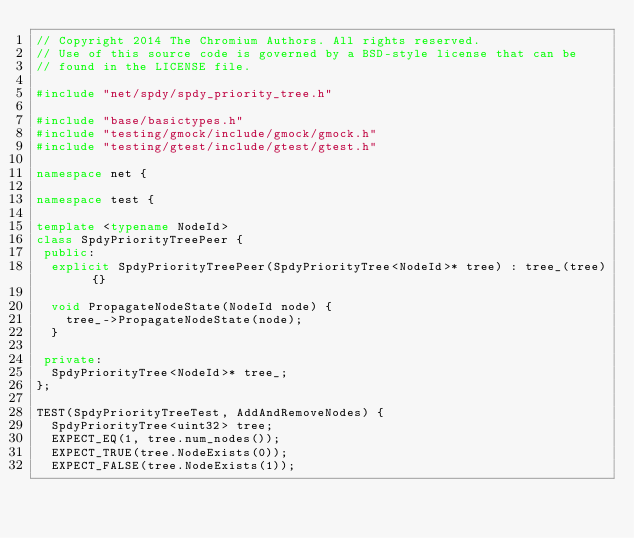Convert code to text. <code><loc_0><loc_0><loc_500><loc_500><_C++_>// Copyright 2014 The Chromium Authors. All rights reserved.
// Use of this source code is governed by a BSD-style license that can be
// found in the LICENSE file.

#include "net/spdy/spdy_priority_tree.h"

#include "base/basictypes.h"
#include "testing/gmock/include/gmock/gmock.h"
#include "testing/gtest/include/gtest/gtest.h"

namespace net {

namespace test {

template <typename NodeId>
class SpdyPriorityTreePeer {
 public:
  explicit SpdyPriorityTreePeer(SpdyPriorityTree<NodeId>* tree) : tree_(tree) {}

  void PropagateNodeState(NodeId node) {
    tree_->PropagateNodeState(node);
  }

 private:
  SpdyPriorityTree<NodeId>* tree_;
};

TEST(SpdyPriorityTreeTest, AddAndRemoveNodes) {
  SpdyPriorityTree<uint32> tree;
  EXPECT_EQ(1, tree.num_nodes());
  EXPECT_TRUE(tree.NodeExists(0));
  EXPECT_FALSE(tree.NodeExists(1));
</code> 